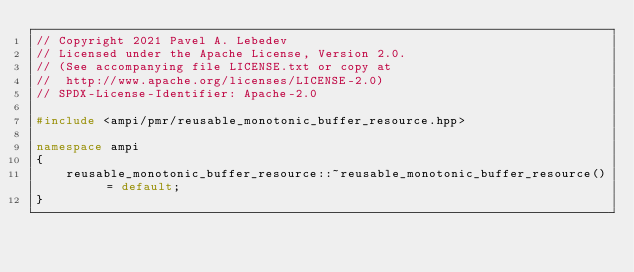<code> <loc_0><loc_0><loc_500><loc_500><_C++_>// Copyright 2021 Pavel A. Lebedev
// Licensed under the Apache License, Version 2.0.
// (See accompanying file LICENSE.txt or copy at
//  http://www.apache.org/licenses/LICENSE-2.0)
// SPDX-License-Identifier: Apache-2.0

#include <ampi/pmr/reusable_monotonic_buffer_resource.hpp>

namespace ampi
{
    reusable_monotonic_buffer_resource::~reusable_monotonic_buffer_resource() = default;
}
</code> 